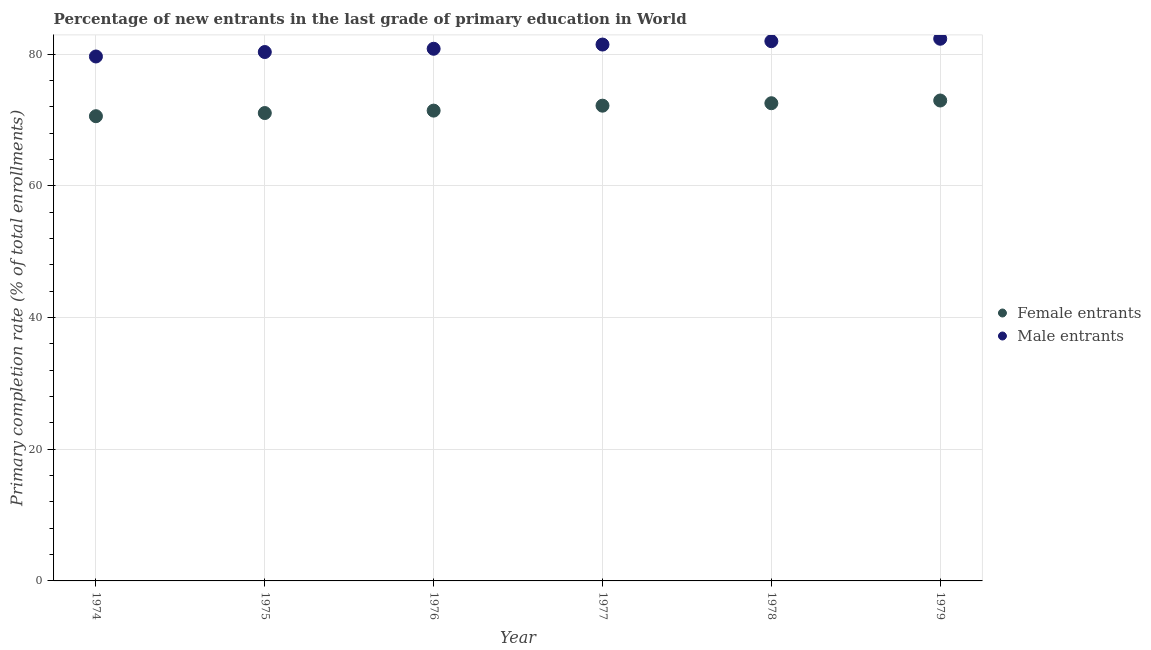How many different coloured dotlines are there?
Your response must be concise. 2. What is the primary completion rate of male entrants in 1974?
Give a very brief answer. 79.65. Across all years, what is the maximum primary completion rate of female entrants?
Provide a succinct answer. 72.96. Across all years, what is the minimum primary completion rate of female entrants?
Offer a terse response. 70.58. In which year was the primary completion rate of male entrants maximum?
Provide a succinct answer. 1979. In which year was the primary completion rate of female entrants minimum?
Your answer should be very brief. 1974. What is the total primary completion rate of female entrants in the graph?
Keep it short and to the point. 430.74. What is the difference between the primary completion rate of male entrants in 1975 and that in 1979?
Ensure brevity in your answer.  -2.02. What is the difference between the primary completion rate of female entrants in 1975 and the primary completion rate of male entrants in 1978?
Offer a very short reply. -10.91. What is the average primary completion rate of female entrants per year?
Keep it short and to the point. 71.79. In the year 1975, what is the difference between the primary completion rate of male entrants and primary completion rate of female entrants?
Ensure brevity in your answer.  9.27. In how many years, is the primary completion rate of male entrants greater than 16 %?
Offer a very short reply. 6. What is the ratio of the primary completion rate of female entrants in 1976 to that in 1979?
Your answer should be very brief. 0.98. Is the difference between the primary completion rate of male entrants in 1977 and 1978 greater than the difference between the primary completion rate of female entrants in 1977 and 1978?
Make the answer very short. No. What is the difference between the highest and the second highest primary completion rate of female entrants?
Your answer should be very brief. 0.41. What is the difference between the highest and the lowest primary completion rate of female entrants?
Your answer should be very brief. 2.38. Is the sum of the primary completion rate of male entrants in 1975 and 1977 greater than the maximum primary completion rate of female entrants across all years?
Offer a terse response. Yes. How many years are there in the graph?
Your response must be concise. 6. Are the values on the major ticks of Y-axis written in scientific E-notation?
Your answer should be very brief. No. Does the graph contain any zero values?
Make the answer very short. No. Where does the legend appear in the graph?
Your answer should be very brief. Center right. What is the title of the graph?
Keep it short and to the point. Percentage of new entrants in the last grade of primary education in World. What is the label or title of the Y-axis?
Keep it short and to the point. Primary completion rate (% of total enrollments). What is the Primary completion rate (% of total enrollments) of Female entrants in 1974?
Offer a very short reply. 70.58. What is the Primary completion rate (% of total enrollments) of Male entrants in 1974?
Provide a short and direct response. 79.65. What is the Primary completion rate (% of total enrollments) in Female entrants in 1975?
Keep it short and to the point. 71.06. What is the Primary completion rate (% of total enrollments) in Male entrants in 1975?
Keep it short and to the point. 80.32. What is the Primary completion rate (% of total enrollments) in Female entrants in 1976?
Give a very brief answer. 71.42. What is the Primary completion rate (% of total enrollments) of Male entrants in 1976?
Keep it short and to the point. 80.82. What is the Primary completion rate (% of total enrollments) of Female entrants in 1977?
Keep it short and to the point. 72.17. What is the Primary completion rate (% of total enrollments) in Male entrants in 1977?
Ensure brevity in your answer.  81.46. What is the Primary completion rate (% of total enrollments) of Female entrants in 1978?
Your answer should be very brief. 72.55. What is the Primary completion rate (% of total enrollments) of Male entrants in 1978?
Provide a succinct answer. 81.97. What is the Primary completion rate (% of total enrollments) in Female entrants in 1979?
Give a very brief answer. 72.96. What is the Primary completion rate (% of total enrollments) of Male entrants in 1979?
Offer a very short reply. 82.34. Across all years, what is the maximum Primary completion rate (% of total enrollments) of Female entrants?
Give a very brief answer. 72.96. Across all years, what is the maximum Primary completion rate (% of total enrollments) in Male entrants?
Ensure brevity in your answer.  82.34. Across all years, what is the minimum Primary completion rate (% of total enrollments) in Female entrants?
Your answer should be very brief. 70.58. Across all years, what is the minimum Primary completion rate (% of total enrollments) of Male entrants?
Your answer should be very brief. 79.65. What is the total Primary completion rate (% of total enrollments) in Female entrants in the graph?
Your answer should be compact. 430.74. What is the total Primary completion rate (% of total enrollments) in Male entrants in the graph?
Your answer should be very brief. 486.55. What is the difference between the Primary completion rate (% of total enrollments) of Female entrants in 1974 and that in 1975?
Offer a very short reply. -0.48. What is the difference between the Primary completion rate (% of total enrollments) in Male entrants in 1974 and that in 1975?
Give a very brief answer. -0.68. What is the difference between the Primary completion rate (% of total enrollments) in Female entrants in 1974 and that in 1976?
Provide a succinct answer. -0.85. What is the difference between the Primary completion rate (% of total enrollments) of Male entrants in 1974 and that in 1976?
Make the answer very short. -1.17. What is the difference between the Primary completion rate (% of total enrollments) in Female entrants in 1974 and that in 1977?
Give a very brief answer. -1.6. What is the difference between the Primary completion rate (% of total enrollments) in Male entrants in 1974 and that in 1977?
Your answer should be very brief. -1.81. What is the difference between the Primary completion rate (% of total enrollments) of Female entrants in 1974 and that in 1978?
Your response must be concise. -1.97. What is the difference between the Primary completion rate (% of total enrollments) of Male entrants in 1974 and that in 1978?
Keep it short and to the point. -2.32. What is the difference between the Primary completion rate (% of total enrollments) in Female entrants in 1974 and that in 1979?
Your answer should be very brief. -2.38. What is the difference between the Primary completion rate (% of total enrollments) in Male entrants in 1974 and that in 1979?
Provide a succinct answer. -2.69. What is the difference between the Primary completion rate (% of total enrollments) of Female entrants in 1975 and that in 1976?
Your answer should be very brief. -0.37. What is the difference between the Primary completion rate (% of total enrollments) in Male entrants in 1975 and that in 1976?
Your answer should be very brief. -0.5. What is the difference between the Primary completion rate (% of total enrollments) in Female entrants in 1975 and that in 1977?
Make the answer very short. -1.12. What is the difference between the Primary completion rate (% of total enrollments) of Male entrants in 1975 and that in 1977?
Ensure brevity in your answer.  -1.14. What is the difference between the Primary completion rate (% of total enrollments) of Female entrants in 1975 and that in 1978?
Make the answer very short. -1.49. What is the difference between the Primary completion rate (% of total enrollments) in Male entrants in 1975 and that in 1978?
Ensure brevity in your answer.  -1.65. What is the difference between the Primary completion rate (% of total enrollments) of Female entrants in 1975 and that in 1979?
Offer a very short reply. -1.9. What is the difference between the Primary completion rate (% of total enrollments) in Male entrants in 1975 and that in 1979?
Offer a very short reply. -2.02. What is the difference between the Primary completion rate (% of total enrollments) of Female entrants in 1976 and that in 1977?
Your response must be concise. -0.75. What is the difference between the Primary completion rate (% of total enrollments) of Male entrants in 1976 and that in 1977?
Offer a very short reply. -0.64. What is the difference between the Primary completion rate (% of total enrollments) of Female entrants in 1976 and that in 1978?
Ensure brevity in your answer.  -1.12. What is the difference between the Primary completion rate (% of total enrollments) in Male entrants in 1976 and that in 1978?
Provide a succinct answer. -1.15. What is the difference between the Primary completion rate (% of total enrollments) in Female entrants in 1976 and that in 1979?
Provide a succinct answer. -1.54. What is the difference between the Primary completion rate (% of total enrollments) of Male entrants in 1976 and that in 1979?
Provide a succinct answer. -1.52. What is the difference between the Primary completion rate (% of total enrollments) of Female entrants in 1977 and that in 1978?
Ensure brevity in your answer.  -0.37. What is the difference between the Primary completion rate (% of total enrollments) in Male entrants in 1977 and that in 1978?
Provide a short and direct response. -0.51. What is the difference between the Primary completion rate (% of total enrollments) of Female entrants in 1977 and that in 1979?
Provide a short and direct response. -0.79. What is the difference between the Primary completion rate (% of total enrollments) in Male entrants in 1977 and that in 1979?
Offer a terse response. -0.88. What is the difference between the Primary completion rate (% of total enrollments) of Female entrants in 1978 and that in 1979?
Give a very brief answer. -0.41. What is the difference between the Primary completion rate (% of total enrollments) of Male entrants in 1978 and that in 1979?
Your answer should be very brief. -0.37. What is the difference between the Primary completion rate (% of total enrollments) in Female entrants in 1974 and the Primary completion rate (% of total enrollments) in Male entrants in 1975?
Your answer should be very brief. -9.75. What is the difference between the Primary completion rate (% of total enrollments) in Female entrants in 1974 and the Primary completion rate (% of total enrollments) in Male entrants in 1976?
Make the answer very short. -10.24. What is the difference between the Primary completion rate (% of total enrollments) in Female entrants in 1974 and the Primary completion rate (% of total enrollments) in Male entrants in 1977?
Ensure brevity in your answer.  -10.88. What is the difference between the Primary completion rate (% of total enrollments) of Female entrants in 1974 and the Primary completion rate (% of total enrollments) of Male entrants in 1978?
Provide a short and direct response. -11.39. What is the difference between the Primary completion rate (% of total enrollments) in Female entrants in 1974 and the Primary completion rate (% of total enrollments) in Male entrants in 1979?
Offer a very short reply. -11.76. What is the difference between the Primary completion rate (% of total enrollments) in Female entrants in 1975 and the Primary completion rate (% of total enrollments) in Male entrants in 1976?
Your response must be concise. -9.76. What is the difference between the Primary completion rate (% of total enrollments) of Female entrants in 1975 and the Primary completion rate (% of total enrollments) of Male entrants in 1977?
Offer a terse response. -10.4. What is the difference between the Primary completion rate (% of total enrollments) of Female entrants in 1975 and the Primary completion rate (% of total enrollments) of Male entrants in 1978?
Offer a terse response. -10.91. What is the difference between the Primary completion rate (% of total enrollments) of Female entrants in 1975 and the Primary completion rate (% of total enrollments) of Male entrants in 1979?
Make the answer very short. -11.28. What is the difference between the Primary completion rate (% of total enrollments) in Female entrants in 1976 and the Primary completion rate (% of total enrollments) in Male entrants in 1977?
Offer a very short reply. -10.03. What is the difference between the Primary completion rate (% of total enrollments) of Female entrants in 1976 and the Primary completion rate (% of total enrollments) of Male entrants in 1978?
Offer a very short reply. -10.55. What is the difference between the Primary completion rate (% of total enrollments) in Female entrants in 1976 and the Primary completion rate (% of total enrollments) in Male entrants in 1979?
Your answer should be very brief. -10.92. What is the difference between the Primary completion rate (% of total enrollments) in Female entrants in 1977 and the Primary completion rate (% of total enrollments) in Male entrants in 1978?
Offer a very short reply. -9.79. What is the difference between the Primary completion rate (% of total enrollments) in Female entrants in 1977 and the Primary completion rate (% of total enrollments) in Male entrants in 1979?
Ensure brevity in your answer.  -10.16. What is the difference between the Primary completion rate (% of total enrollments) in Female entrants in 1978 and the Primary completion rate (% of total enrollments) in Male entrants in 1979?
Your answer should be compact. -9.79. What is the average Primary completion rate (% of total enrollments) in Female entrants per year?
Your response must be concise. 71.79. What is the average Primary completion rate (% of total enrollments) of Male entrants per year?
Keep it short and to the point. 81.09. In the year 1974, what is the difference between the Primary completion rate (% of total enrollments) in Female entrants and Primary completion rate (% of total enrollments) in Male entrants?
Offer a very short reply. -9.07. In the year 1975, what is the difference between the Primary completion rate (% of total enrollments) in Female entrants and Primary completion rate (% of total enrollments) in Male entrants?
Provide a short and direct response. -9.27. In the year 1976, what is the difference between the Primary completion rate (% of total enrollments) in Female entrants and Primary completion rate (% of total enrollments) in Male entrants?
Keep it short and to the point. -9.39. In the year 1977, what is the difference between the Primary completion rate (% of total enrollments) of Female entrants and Primary completion rate (% of total enrollments) of Male entrants?
Ensure brevity in your answer.  -9.28. In the year 1978, what is the difference between the Primary completion rate (% of total enrollments) of Female entrants and Primary completion rate (% of total enrollments) of Male entrants?
Your answer should be compact. -9.42. In the year 1979, what is the difference between the Primary completion rate (% of total enrollments) in Female entrants and Primary completion rate (% of total enrollments) in Male entrants?
Provide a short and direct response. -9.38. What is the ratio of the Primary completion rate (% of total enrollments) of Female entrants in 1974 to that in 1975?
Keep it short and to the point. 0.99. What is the ratio of the Primary completion rate (% of total enrollments) in Male entrants in 1974 to that in 1975?
Provide a short and direct response. 0.99. What is the ratio of the Primary completion rate (% of total enrollments) in Male entrants in 1974 to that in 1976?
Make the answer very short. 0.99. What is the ratio of the Primary completion rate (% of total enrollments) of Female entrants in 1974 to that in 1977?
Your response must be concise. 0.98. What is the ratio of the Primary completion rate (% of total enrollments) in Male entrants in 1974 to that in 1977?
Ensure brevity in your answer.  0.98. What is the ratio of the Primary completion rate (% of total enrollments) of Female entrants in 1974 to that in 1978?
Make the answer very short. 0.97. What is the ratio of the Primary completion rate (% of total enrollments) of Male entrants in 1974 to that in 1978?
Make the answer very short. 0.97. What is the ratio of the Primary completion rate (% of total enrollments) in Female entrants in 1974 to that in 1979?
Offer a terse response. 0.97. What is the ratio of the Primary completion rate (% of total enrollments) in Male entrants in 1974 to that in 1979?
Offer a very short reply. 0.97. What is the ratio of the Primary completion rate (% of total enrollments) of Male entrants in 1975 to that in 1976?
Provide a succinct answer. 0.99. What is the ratio of the Primary completion rate (% of total enrollments) in Female entrants in 1975 to that in 1977?
Provide a short and direct response. 0.98. What is the ratio of the Primary completion rate (% of total enrollments) of Male entrants in 1975 to that in 1977?
Make the answer very short. 0.99. What is the ratio of the Primary completion rate (% of total enrollments) in Female entrants in 1975 to that in 1978?
Offer a terse response. 0.98. What is the ratio of the Primary completion rate (% of total enrollments) of Male entrants in 1975 to that in 1978?
Offer a very short reply. 0.98. What is the ratio of the Primary completion rate (% of total enrollments) of Female entrants in 1975 to that in 1979?
Your response must be concise. 0.97. What is the ratio of the Primary completion rate (% of total enrollments) in Male entrants in 1975 to that in 1979?
Provide a short and direct response. 0.98. What is the ratio of the Primary completion rate (% of total enrollments) in Male entrants in 1976 to that in 1977?
Your answer should be compact. 0.99. What is the ratio of the Primary completion rate (% of total enrollments) in Female entrants in 1976 to that in 1978?
Provide a short and direct response. 0.98. What is the ratio of the Primary completion rate (% of total enrollments) in Male entrants in 1976 to that in 1978?
Your answer should be very brief. 0.99. What is the ratio of the Primary completion rate (% of total enrollments) of Female entrants in 1976 to that in 1979?
Give a very brief answer. 0.98. What is the ratio of the Primary completion rate (% of total enrollments) in Male entrants in 1976 to that in 1979?
Your answer should be compact. 0.98. What is the ratio of the Primary completion rate (% of total enrollments) in Female entrants in 1977 to that in 1978?
Your response must be concise. 0.99. What is the ratio of the Primary completion rate (% of total enrollments) in Male entrants in 1977 to that in 1978?
Provide a short and direct response. 0.99. What is the ratio of the Primary completion rate (% of total enrollments) of Male entrants in 1977 to that in 1979?
Your response must be concise. 0.99. What is the ratio of the Primary completion rate (% of total enrollments) of Female entrants in 1978 to that in 1979?
Ensure brevity in your answer.  0.99. What is the difference between the highest and the second highest Primary completion rate (% of total enrollments) of Female entrants?
Offer a terse response. 0.41. What is the difference between the highest and the second highest Primary completion rate (% of total enrollments) in Male entrants?
Provide a short and direct response. 0.37. What is the difference between the highest and the lowest Primary completion rate (% of total enrollments) of Female entrants?
Your answer should be very brief. 2.38. What is the difference between the highest and the lowest Primary completion rate (% of total enrollments) in Male entrants?
Your answer should be compact. 2.69. 